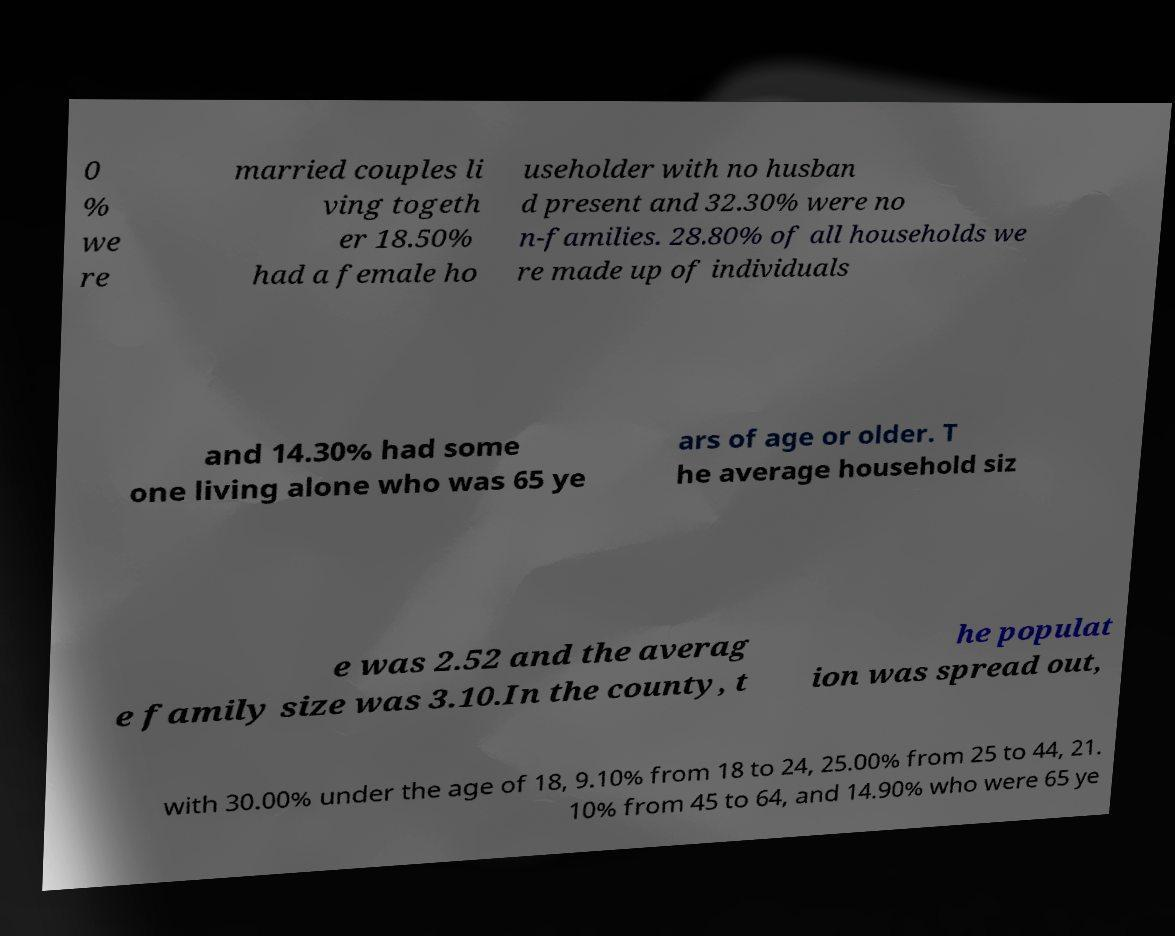Could you assist in decoding the text presented in this image and type it out clearly? 0 % we re married couples li ving togeth er 18.50% had a female ho useholder with no husban d present and 32.30% were no n-families. 28.80% of all households we re made up of individuals and 14.30% had some one living alone who was 65 ye ars of age or older. T he average household siz e was 2.52 and the averag e family size was 3.10.In the county, t he populat ion was spread out, with 30.00% under the age of 18, 9.10% from 18 to 24, 25.00% from 25 to 44, 21. 10% from 45 to 64, and 14.90% who were 65 ye 